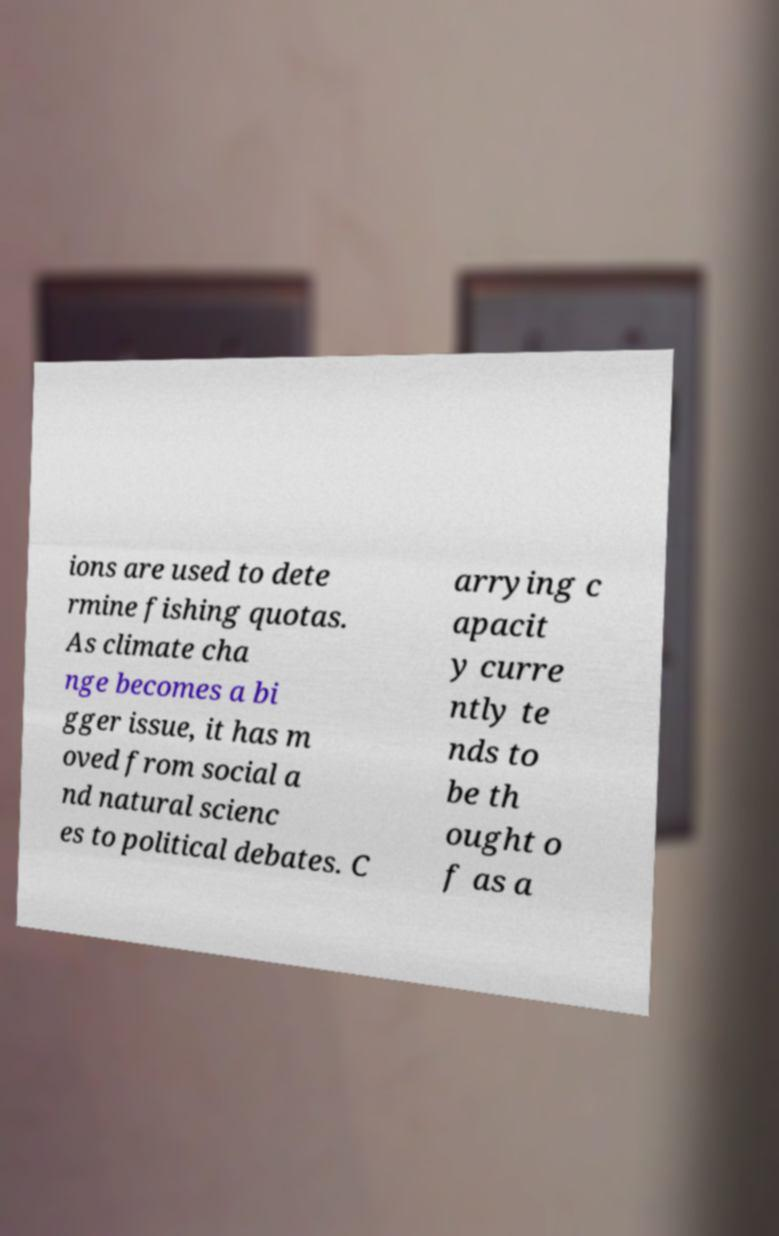I need the written content from this picture converted into text. Can you do that? ions are used to dete rmine fishing quotas. As climate cha nge becomes a bi gger issue, it has m oved from social a nd natural scienc es to political debates. C arrying c apacit y curre ntly te nds to be th ought o f as a 